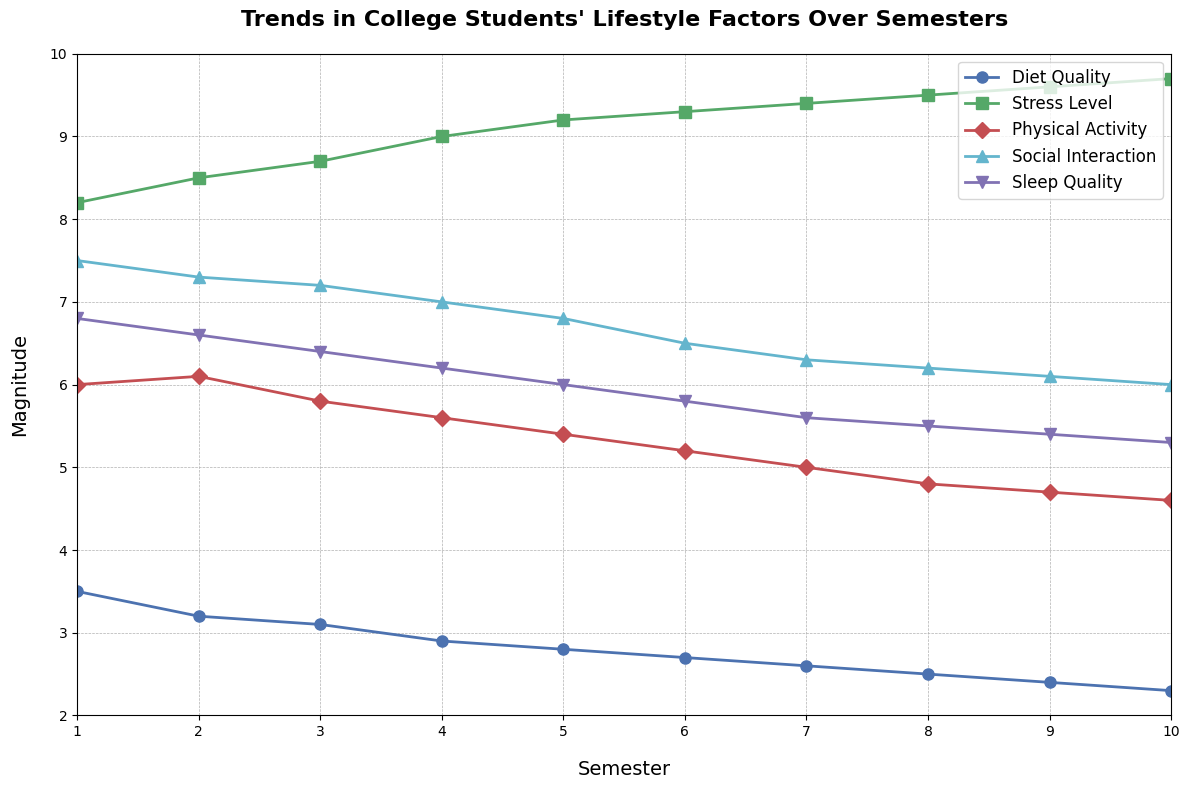What is the Diet Quality trend over the semesters? The plot shows a decline in Diet Quality from approximately 3.5 in Semester 1 to 2.3 in Semester 10. This is observed by following the blue line with 'o' markers through the semesters.
Answer: Decline Which lifestyle factor has the highest value in Semester 1? Observing the plot for Semester 1, the highest value among the factors is Stress Level, represented by the green line with 's' markers, at 8.2.
Answer: Stress Level What is the difference in Stress Level between Semester 1 and Semester 10? The Stress Level in Semester 1 is 8.2, and in Semester 10 it is 9.7. The difference is calculated as 9.7 - 8.2.
Answer: 1.5 By how much did Sleep Quality decrease from Semester 1 to Semester 8? Sleep Quality in Semester 1 is 6.8, and in Semester 8 it is 5.5. The decrease is calculated as 6.8 - 5.5.
Answer: 1.3 Which semester shows the steepest decrease in Physical Activity? The steepest decrease in Physical Activity appears between Semesters 1 and 2, where the red line with 'D' markers drops from 6.0 to 5.8.
Answer: Semester 1 to 2 Between which semesters does Social Interaction show the least change? Social Interaction shows the least change between Semesters 8 and 9, where it decreases minimally from 6.2 to 6.1, as indicated by the cyan line with '^' markers.
Answer: Semester 8 to 9 Which lifestyle factors become worse (values increase) from Semester 5 to Semester 6 and by how much? Comparing the values from Semester 5 to Semester 6, Stress Level increases from 9.2 to 9.3, by 0.1.
Answer: Stress Level, 0.1 How does Sleep Quality change in the second half of the semesters (from 6 to 10)? Sleep Quality starts at 5.8 in Semester 6 and decreases gradually to 5.3 by Semester 10 as shown by the magenta line with 'v' markers.
Answer: Decreases From Semester 3 to 7, what is the average change in Physical Activity per semester? The Physical Activity values are 5.8, 5.6, 5.4, 5.2, and 5.0 for Semesters 3 through 7. The changes per semester are -0.2 each, so the average change is the mean of these values. Sum these changes (-0.2 * 4 = -0.8) and divide by the number of changes (4), giving -0.8 / 4.
Answer: -0.2 